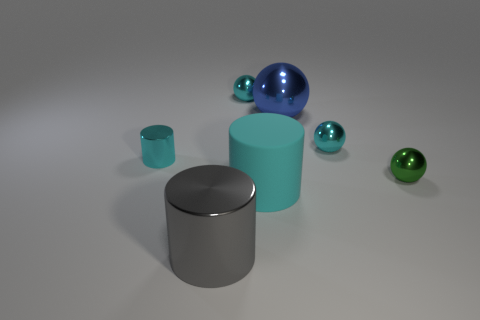Add 3 red cylinders. How many objects exist? 10 Subtract all cylinders. How many objects are left? 4 Add 3 green spheres. How many green spheres are left? 4 Add 2 big cylinders. How many big cylinders exist? 4 Subtract 0 gray balls. How many objects are left? 7 Subtract all large shiny balls. Subtract all big purple metallic blocks. How many objects are left? 6 